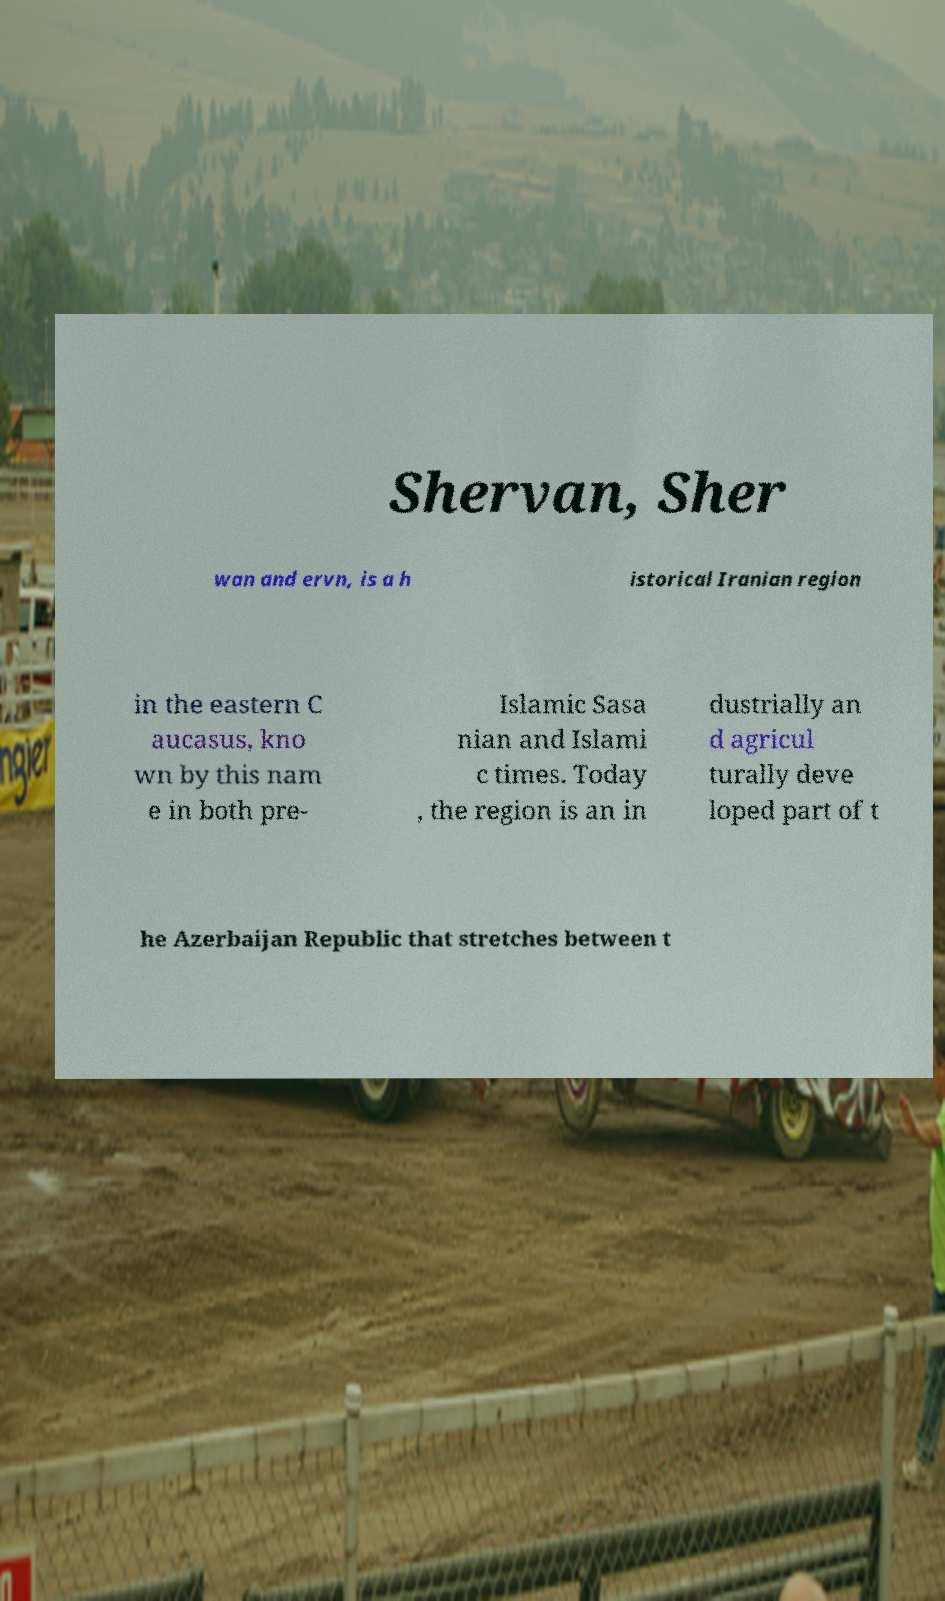There's text embedded in this image that I need extracted. Can you transcribe it verbatim? Shervan, Sher wan and ervn, is a h istorical Iranian region in the eastern C aucasus, kno wn by this nam e in both pre- Islamic Sasa nian and Islami c times. Today , the region is an in dustrially an d agricul turally deve loped part of t he Azerbaijan Republic that stretches between t 